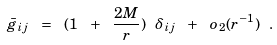Convert formula to latex. <formula><loc_0><loc_0><loc_500><loc_500>\bar { g } _ { i j } \ = \ ( 1 \ + \ \frac { 2 M } { r } ) \ \delta _ { i j } \ + \ o _ { 2 } ( r ^ { - 1 } ) \ .</formula> 